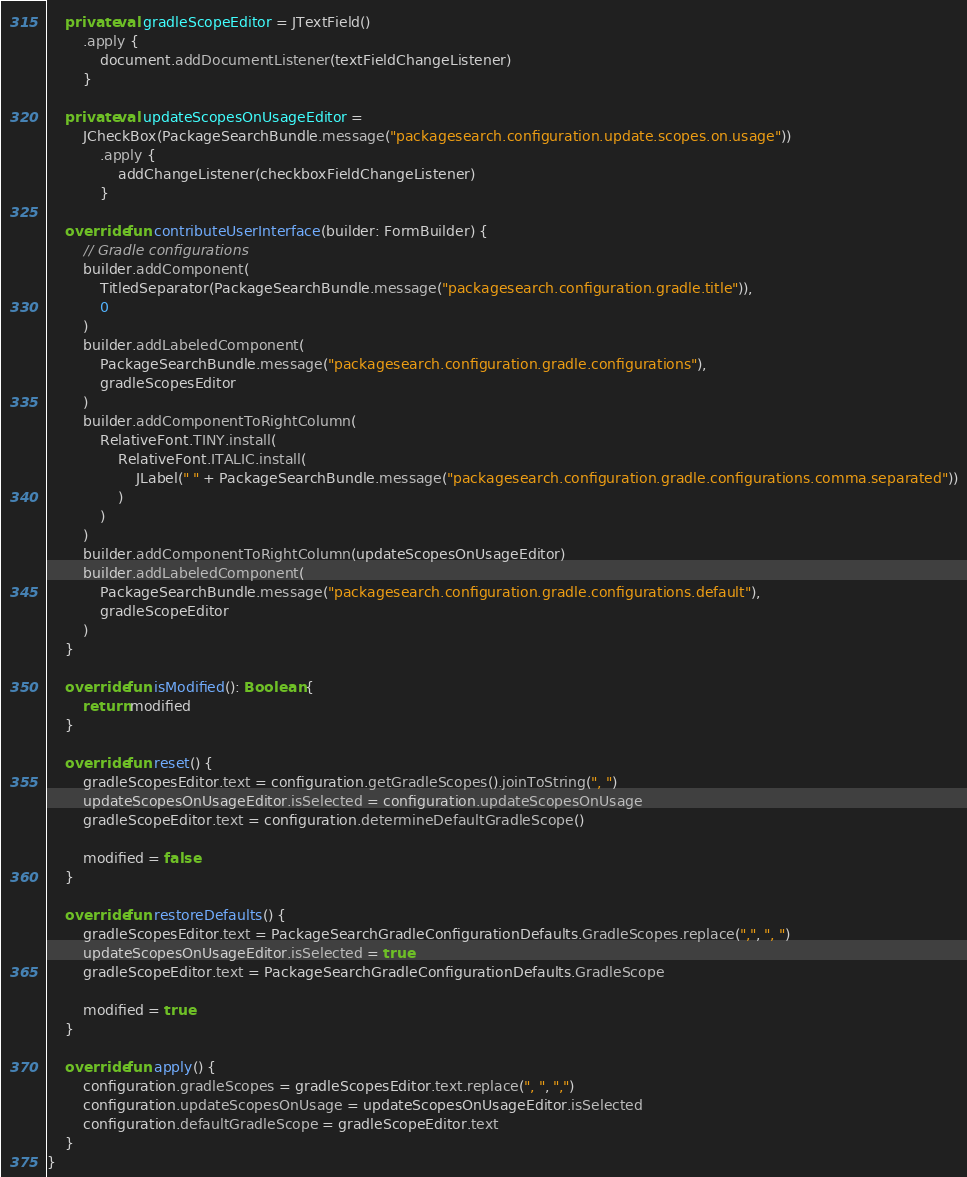Convert code to text. <code><loc_0><loc_0><loc_500><loc_500><_Kotlin_>
    private val gradleScopeEditor = JTextField()
        .apply {
            document.addDocumentListener(textFieldChangeListener)
        }

    private val updateScopesOnUsageEditor =
        JCheckBox(PackageSearchBundle.message("packagesearch.configuration.update.scopes.on.usage"))
            .apply {
                addChangeListener(checkboxFieldChangeListener)
            }

    override fun contributeUserInterface(builder: FormBuilder) {
        // Gradle configurations
        builder.addComponent(
            TitledSeparator(PackageSearchBundle.message("packagesearch.configuration.gradle.title")),
            0
        )
        builder.addLabeledComponent(
            PackageSearchBundle.message("packagesearch.configuration.gradle.configurations"),
            gradleScopesEditor
        )
        builder.addComponentToRightColumn(
            RelativeFont.TINY.install(
                RelativeFont.ITALIC.install(
                    JLabel(" " + PackageSearchBundle.message("packagesearch.configuration.gradle.configurations.comma.separated"))
                )
            )
        )
        builder.addComponentToRightColumn(updateScopesOnUsageEditor)
        builder.addLabeledComponent(
            PackageSearchBundle.message("packagesearch.configuration.gradle.configurations.default"),
            gradleScopeEditor
        )
    }

    override fun isModified(): Boolean {
        return modified
    }

    override fun reset() {
        gradleScopesEditor.text = configuration.getGradleScopes().joinToString(", ")
        updateScopesOnUsageEditor.isSelected = configuration.updateScopesOnUsage
        gradleScopeEditor.text = configuration.determineDefaultGradleScope()

        modified = false
    }

    override fun restoreDefaults() {
        gradleScopesEditor.text = PackageSearchGradleConfigurationDefaults.GradleScopes.replace(",", ", ")
        updateScopesOnUsageEditor.isSelected = true
        gradleScopeEditor.text = PackageSearchGradleConfigurationDefaults.GradleScope

        modified = true
    }

    override fun apply() {
        configuration.gradleScopes = gradleScopesEditor.text.replace(", ", ",")
        configuration.updateScopesOnUsage = updateScopesOnUsageEditor.isSelected
        configuration.defaultGradleScope = gradleScopeEditor.text
    }
}
</code> 